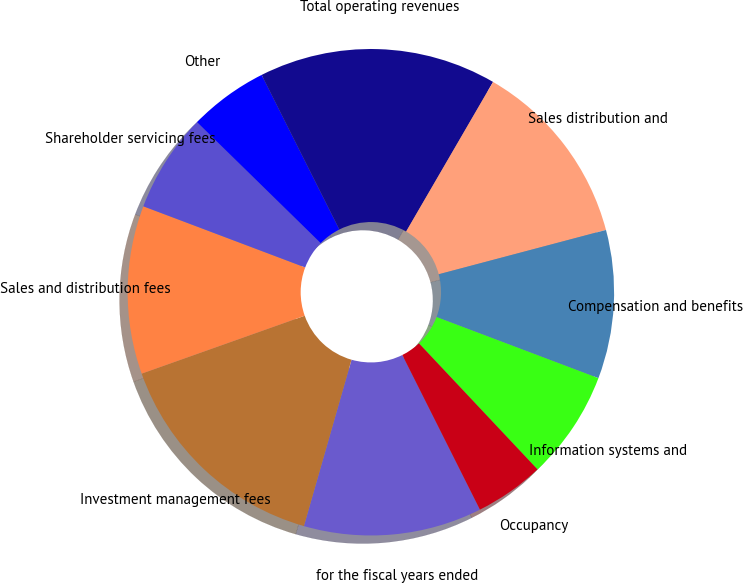Convert chart. <chart><loc_0><loc_0><loc_500><loc_500><pie_chart><fcel>for the fiscal years ended<fcel>Investment management fees<fcel>Sales and distribution fees<fcel>Shareholder servicing fees<fcel>Other<fcel>Total operating revenues<fcel>Sales distribution and<fcel>Compensation and benefits<fcel>Information systems and<fcel>Occupancy<nl><fcel>11.84%<fcel>15.13%<fcel>11.18%<fcel>6.58%<fcel>5.26%<fcel>15.79%<fcel>12.5%<fcel>9.87%<fcel>7.24%<fcel>4.61%<nl></chart> 